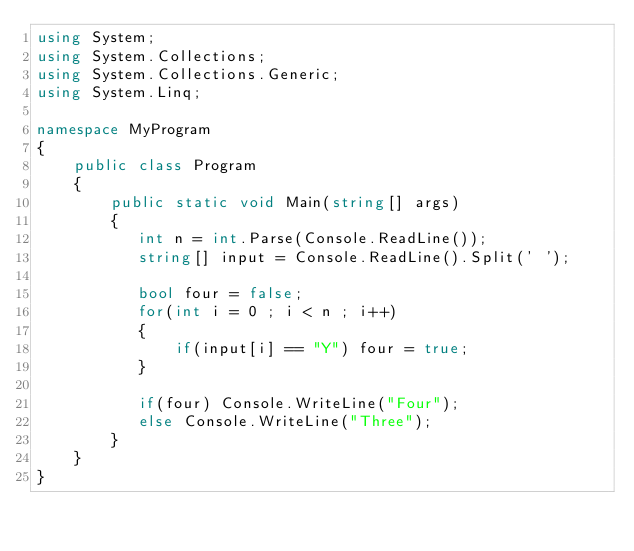<code> <loc_0><loc_0><loc_500><loc_500><_C#_>using System;
using System.Collections;
using System.Collections.Generic;
using System.Linq;

namespace MyProgram
{
    public class Program
    {	
        public static void Main(string[] args)
        {
           int n = int.Parse(Console.ReadLine());
           string[] input = Console.ReadLine().Split(' ');
           
           bool four = false;
           for(int i = 0 ; i < n ; i++)
           {
               if(input[i] == "Y") four = true;
           }
           
           if(four) Console.WriteLine("Four");
           else Console.WriteLine("Three");
        }
    }
}</code> 